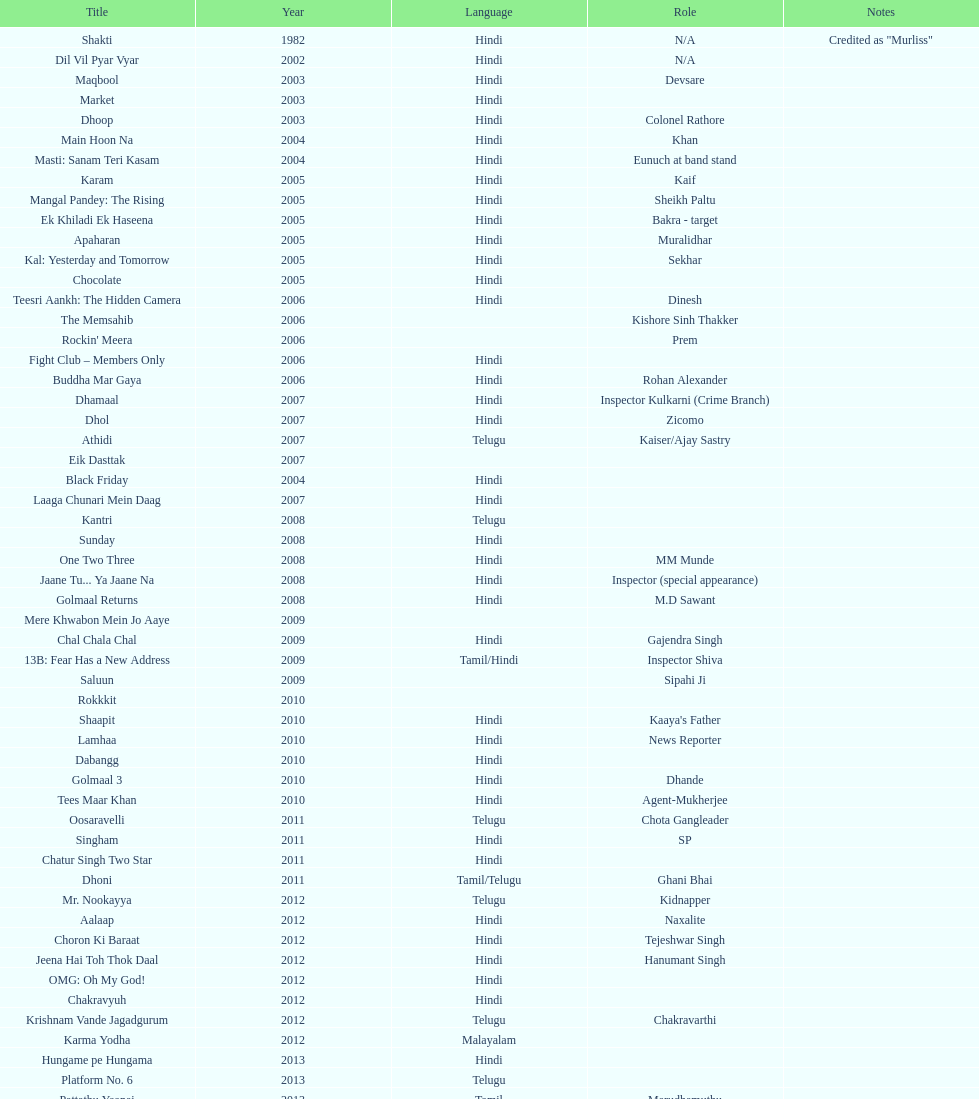What is the count of titles listed in 2005? 6. 